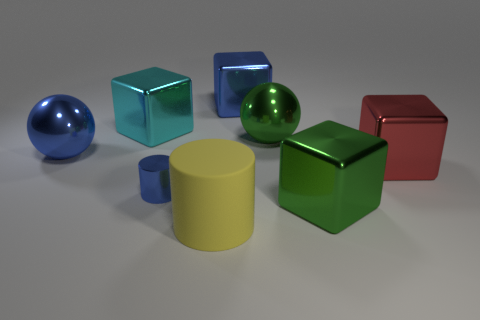Subtract 1 cubes. How many cubes are left? 3 Subtract all green spheres. Subtract all gray blocks. How many spheres are left? 1 Add 2 big yellow shiny cylinders. How many objects exist? 10 Subtract all cylinders. How many objects are left? 6 Subtract all big blue objects. Subtract all small blue things. How many objects are left? 5 Add 6 big yellow cylinders. How many big yellow cylinders are left? 7 Add 2 matte cubes. How many matte cubes exist? 2 Subtract 0 purple cylinders. How many objects are left? 8 